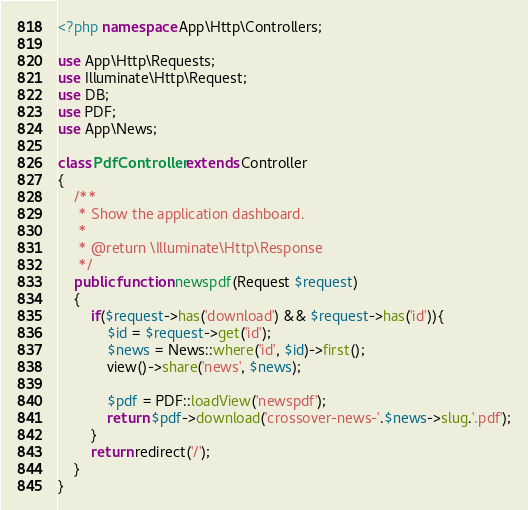<code> <loc_0><loc_0><loc_500><loc_500><_PHP_><?php namespace App\Http\Controllers;

use App\Http\Requests;
use Illuminate\Http\Request;
use DB;
use PDF;
use App\News;

class PdfController extends Controller
{
    /**
     * Show the application dashboard.
     *
     * @return \Illuminate\Http\Response
     */
    public function newspdf(Request $request)
    {
        if($request->has('download') && $request->has('id')){
            $id = $request->get('id');
            $news = News::where('id', $id)->first();
            view()->share('news', $news);

            $pdf = PDF::loadView('newspdf');
            return $pdf->download('crossover-news-'.$news->slug.'.pdf');
        }
        return redirect('/');
    }
}</code> 